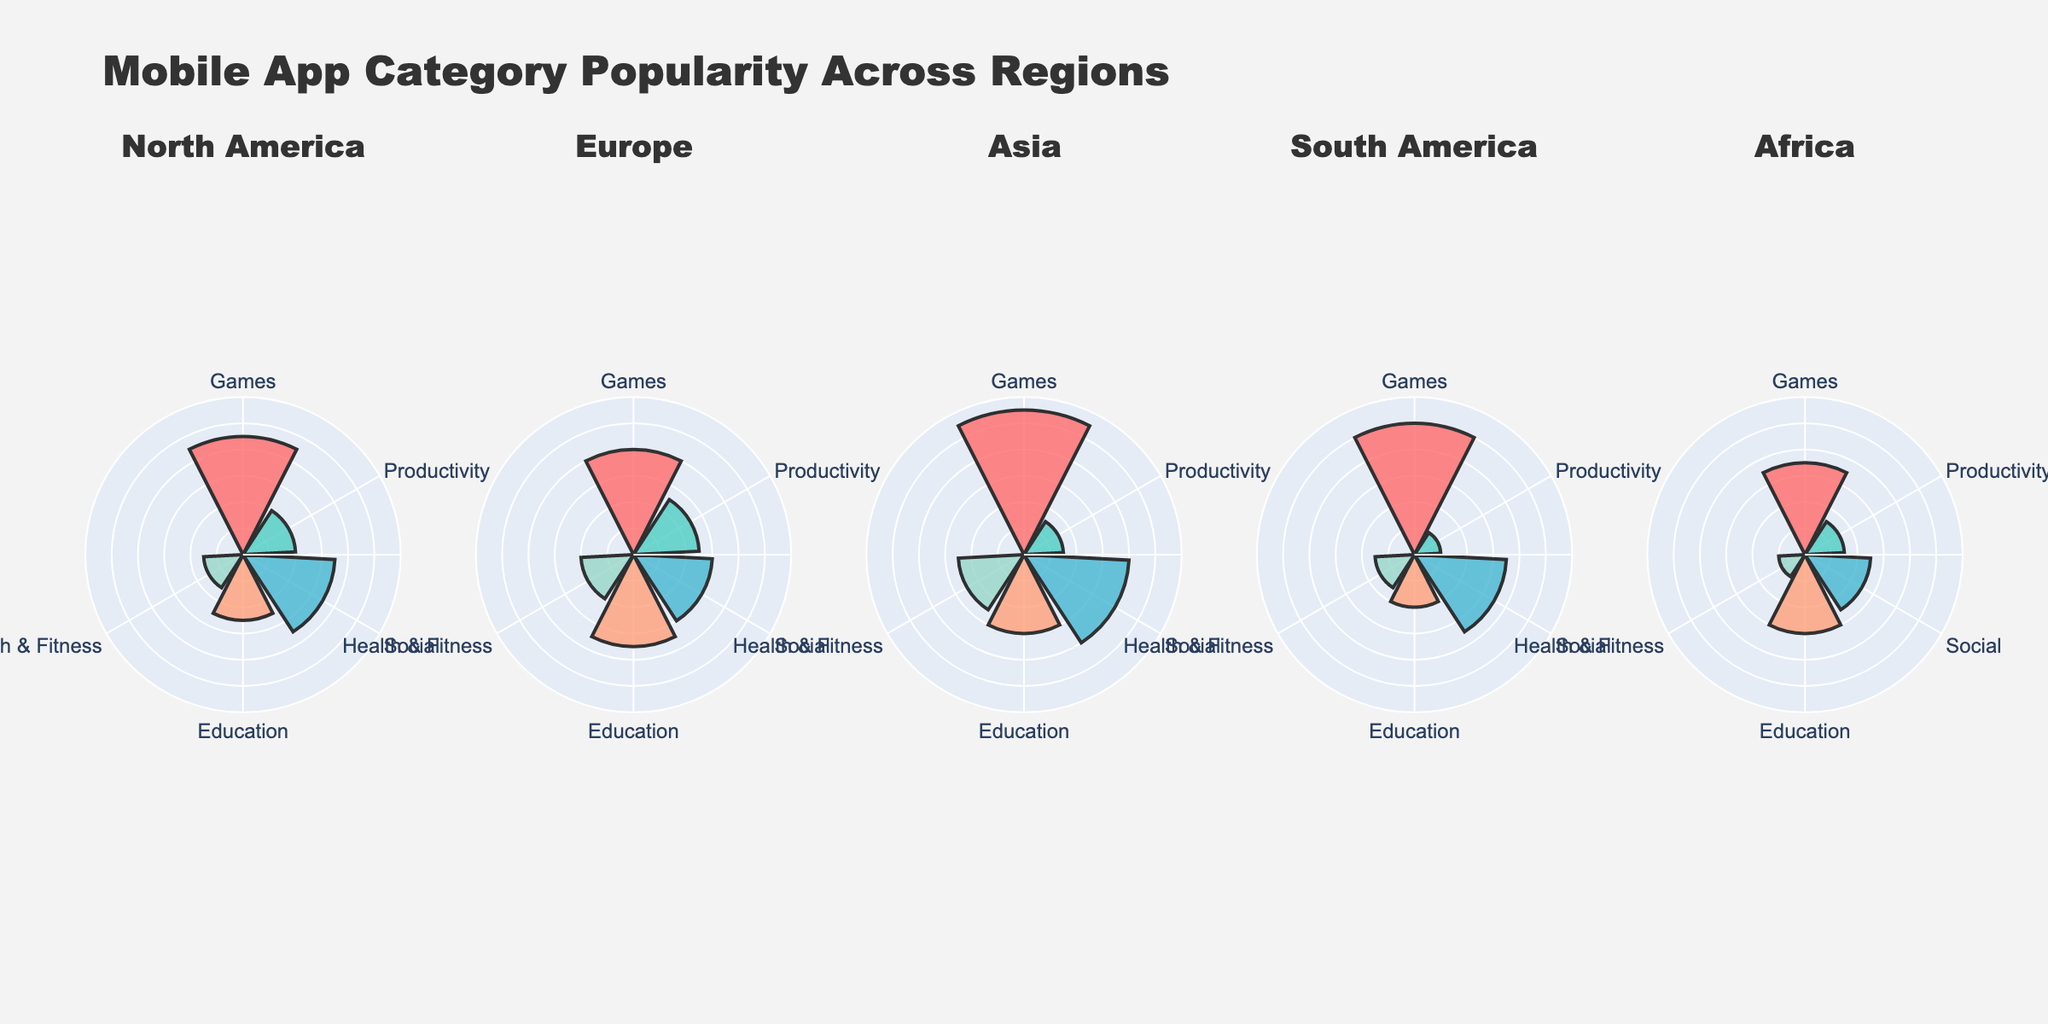What is the most popular app category in North America? In North America, Games have the highest popularity. Looking at the North America subplot, Games have the longest bar extending to 45%.
Answer: Games What is the least popular app category in South America? The least popular app category in South America is Productivity with a popularity of 10%, as shown by the shortest bar in the South America subplot.
Answer: Productivity Compare the popularity of Social apps between Europe and Asia. Which region has higher popularity for Social apps? In Europe, the Social apps have a popularity of 30%. In Asia, Social apps have a popularity of 40%. Hence, Asia has higher popularity for Social apps.
Answer: Asia What are the two most popular app categories in Europe? The European subplot shows that Education and Games are the most popular categories with popularity scores of 35% and 40%, respectively.
Answer: Education, Games What is the combined popularity of Productivity and Health & Fitness categories in Africa? For Africa, Productivity has a popularity of 15% and Health & Fitness has 10%. Combined popularity is 15 + 10 = 25%.
Answer: 25% Which region has the lowest popularity for Health & Fitness apps? The African subplot indicates that the Health & Fitness category has the lowest popularity of 10%. This is the lowest among all regions.
Answer: Africa How much more popular are Games in Asia compared to Europe? Games have a popularity of 55% in Asia and 40% in Europe. The difference in popularity is 55 - 40 = 15%.
Answer: 15% Rank the regions based on the popularity of Education apps from highest to lowest. From the subplots, the popularity of Education apps is 35% in Europe, 30% in Asia and Africa, 25% in North America, and 20% in South America. So, the ranking is: Europe, Asia, Africa, North America, South America.
Answer: Europe, Asia, Africa, North America, South America Which app category shows the most consistent popularity across all regions? By observing all subplots, the Social category maintains relatively high consistency in popularity across regions: North America (35%), Europe (30%), Asia (40%), South America (35%), and Africa (25%).
Answer: Social 